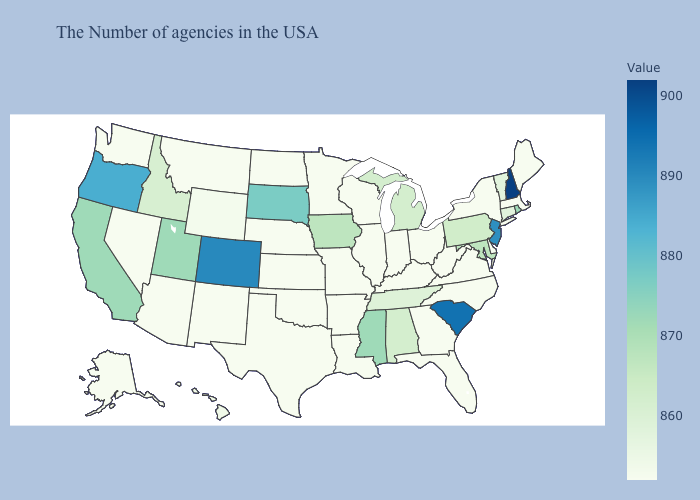Does Iowa have the lowest value in the MidWest?
Quick response, please. No. Does Arizona have the lowest value in the USA?
Concise answer only. Yes. Does South Dakota have the highest value in the MidWest?
Quick response, please. Yes. Among the states that border North Carolina , does Tennessee have the lowest value?
Give a very brief answer. No. Does Michigan have the lowest value in the MidWest?
Concise answer only. No. 